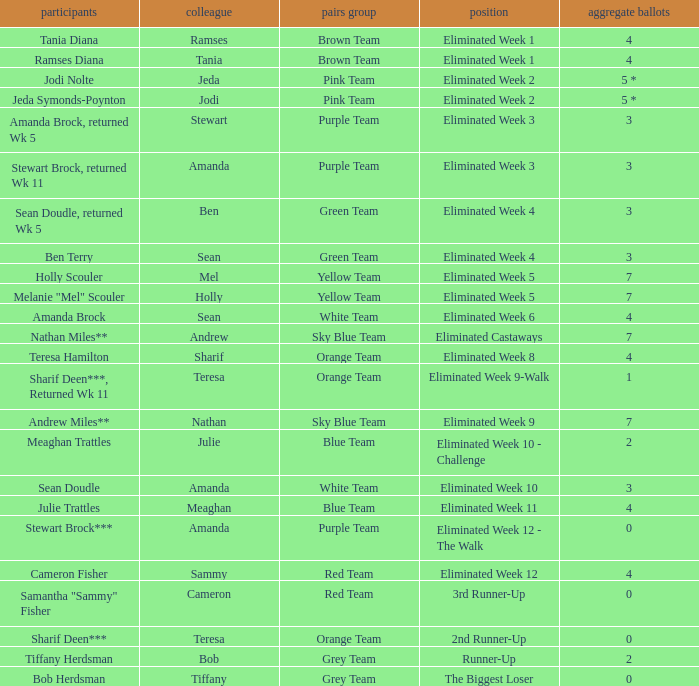Who had 0 total votes in the purple team? Eliminated Week 12 - The Walk. 